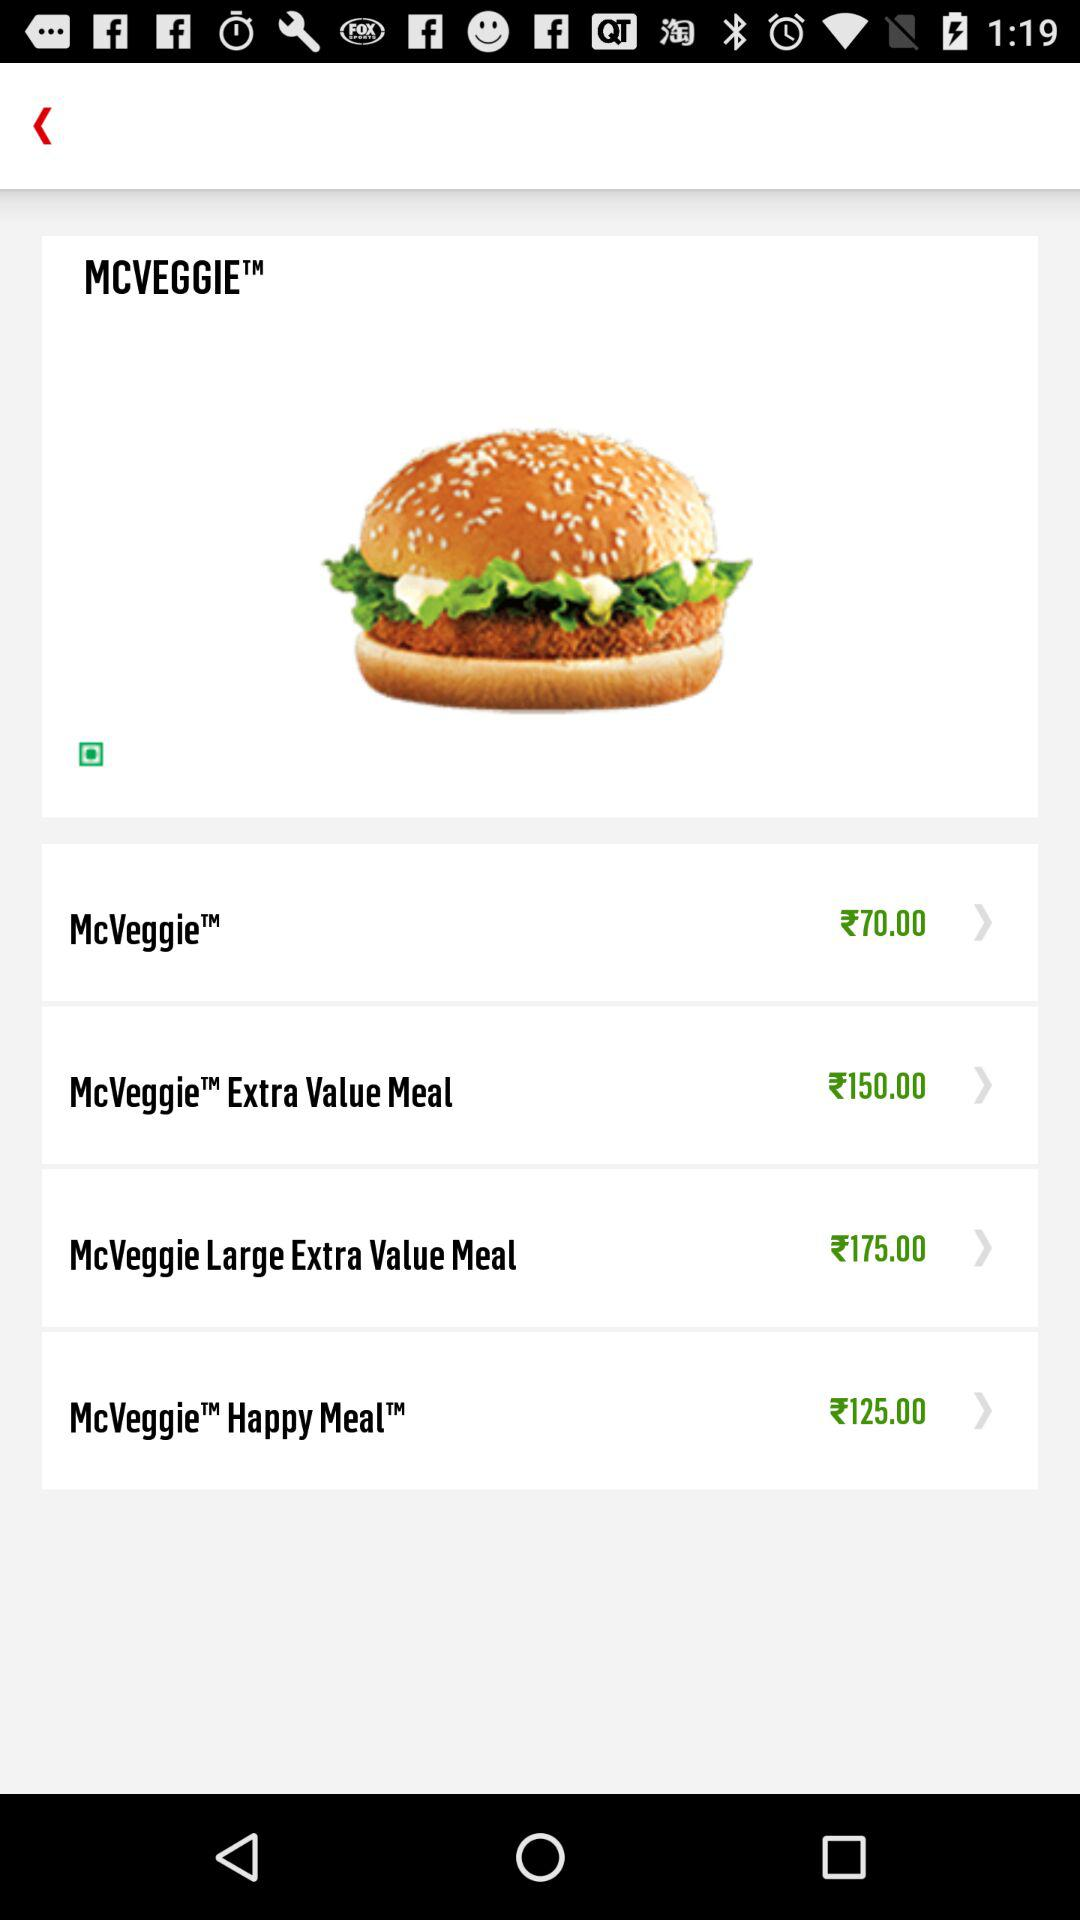How much more expensive is the McVeggie Large Extra Value Meal than the McVeggie Happy MealTM?
Answer the question using a single word or phrase. €50.00 